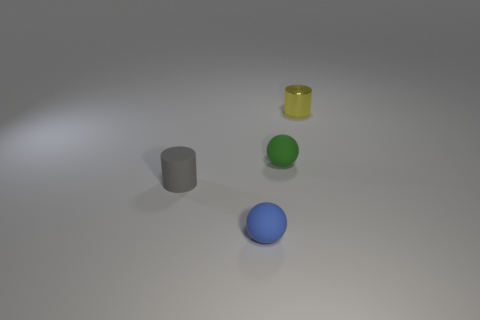Add 1 tiny blue objects. How many objects exist? 5 Subtract all small metallic things. Subtract all gray metal objects. How many objects are left? 3 Add 1 shiny cylinders. How many shiny cylinders are left? 2 Add 3 tiny gray rubber objects. How many tiny gray rubber objects exist? 4 Subtract 0 red balls. How many objects are left? 4 